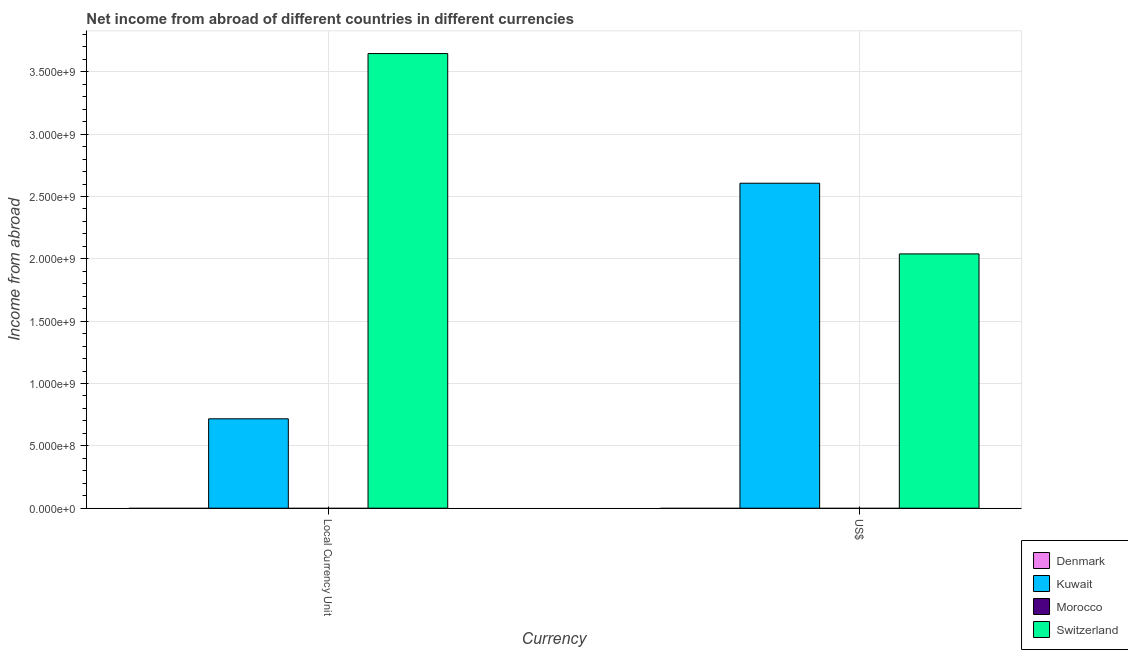How many different coloured bars are there?
Make the answer very short. 2. Are the number of bars per tick equal to the number of legend labels?
Offer a very short reply. No. How many bars are there on the 1st tick from the left?
Your answer should be very brief. 2. What is the label of the 1st group of bars from the left?
Keep it short and to the point. Local Currency Unit. What is the income from abroad in constant 2005 us$ in Switzerland?
Offer a very short reply. 3.65e+09. Across all countries, what is the maximum income from abroad in constant 2005 us$?
Keep it short and to the point. 3.65e+09. Across all countries, what is the minimum income from abroad in us$?
Your answer should be compact. 0. In which country was the income from abroad in constant 2005 us$ maximum?
Provide a succinct answer. Switzerland. What is the total income from abroad in us$ in the graph?
Your answer should be compact. 4.65e+09. What is the difference between the income from abroad in constant 2005 us$ in Switzerland and that in Kuwait?
Give a very brief answer. 2.93e+09. What is the difference between the income from abroad in us$ in Kuwait and the income from abroad in constant 2005 us$ in Morocco?
Make the answer very short. 2.61e+09. What is the average income from abroad in us$ per country?
Your answer should be very brief. 1.16e+09. What is the difference between the income from abroad in us$ and income from abroad in constant 2005 us$ in Kuwait?
Offer a very short reply. 1.89e+09. In how many countries, is the income from abroad in constant 2005 us$ greater than 2500000000 units?
Offer a very short reply. 1. In how many countries, is the income from abroad in us$ greater than the average income from abroad in us$ taken over all countries?
Offer a very short reply. 2. How many countries are there in the graph?
Offer a terse response. 4. Are the values on the major ticks of Y-axis written in scientific E-notation?
Offer a very short reply. Yes. Where does the legend appear in the graph?
Make the answer very short. Bottom right. How are the legend labels stacked?
Make the answer very short. Vertical. What is the title of the graph?
Keep it short and to the point. Net income from abroad of different countries in different currencies. What is the label or title of the X-axis?
Provide a succinct answer. Currency. What is the label or title of the Y-axis?
Your response must be concise. Income from abroad. What is the Income from abroad of Kuwait in Local Currency Unit?
Give a very brief answer. 7.17e+08. What is the Income from abroad of Switzerland in Local Currency Unit?
Ensure brevity in your answer.  3.65e+09. What is the Income from abroad of Denmark in US$?
Your response must be concise. 0. What is the Income from abroad in Kuwait in US$?
Provide a short and direct response. 2.61e+09. What is the Income from abroad in Morocco in US$?
Give a very brief answer. 0. What is the Income from abroad in Switzerland in US$?
Offer a very short reply. 2.04e+09. Across all Currency, what is the maximum Income from abroad of Kuwait?
Make the answer very short. 2.61e+09. Across all Currency, what is the maximum Income from abroad in Switzerland?
Offer a very short reply. 3.65e+09. Across all Currency, what is the minimum Income from abroad in Kuwait?
Ensure brevity in your answer.  7.17e+08. Across all Currency, what is the minimum Income from abroad of Switzerland?
Your answer should be very brief. 2.04e+09. What is the total Income from abroad in Denmark in the graph?
Keep it short and to the point. 0. What is the total Income from abroad in Kuwait in the graph?
Ensure brevity in your answer.  3.32e+09. What is the total Income from abroad in Switzerland in the graph?
Offer a terse response. 5.69e+09. What is the difference between the Income from abroad in Kuwait in Local Currency Unit and that in US$?
Keep it short and to the point. -1.89e+09. What is the difference between the Income from abroad in Switzerland in Local Currency Unit and that in US$?
Offer a terse response. 1.61e+09. What is the difference between the Income from abroad of Kuwait in Local Currency Unit and the Income from abroad of Switzerland in US$?
Your answer should be very brief. -1.32e+09. What is the average Income from abroad in Kuwait per Currency?
Your response must be concise. 1.66e+09. What is the average Income from abroad in Switzerland per Currency?
Offer a very short reply. 2.84e+09. What is the difference between the Income from abroad of Kuwait and Income from abroad of Switzerland in Local Currency Unit?
Your answer should be compact. -2.93e+09. What is the difference between the Income from abroad in Kuwait and Income from abroad in Switzerland in US$?
Ensure brevity in your answer.  5.67e+08. What is the ratio of the Income from abroad of Kuwait in Local Currency Unit to that in US$?
Ensure brevity in your answer.  0.28. What is the ratio of the Income from abroad of Switzerland in Local Currency Unit to that in US$?
Your answer should be compact. 1.79. What is the difference between the highest and the second highest Income from abroad in Kuwait?
Your response must be concise. 1.89e+09. What is the difference between the highest and the second highest Income from abroad in Switzerland?
Your answer should be compact. 1.61e+09. What is the difference between the highest and the lowest Income from abroad in Kuwait?
Offer a very short reply. 1.89e+09. What is the difference between the highest and the lowest Income from abroad of Switzerland?
Give a very brief answer. 1.61e+09. 